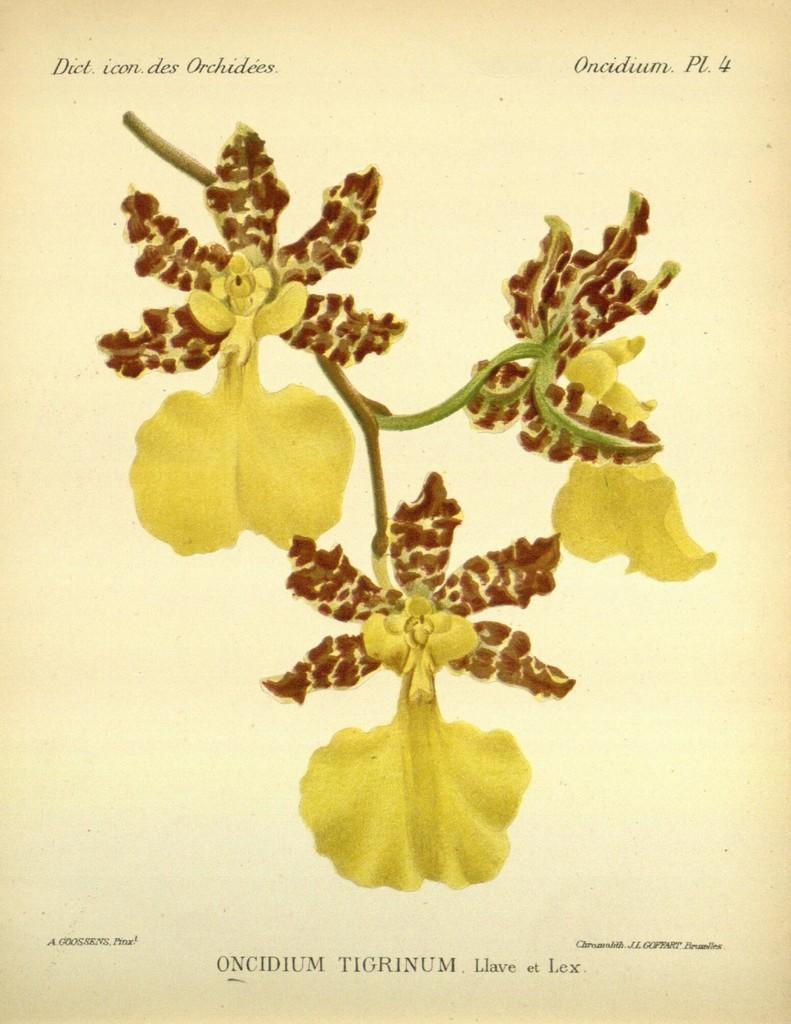<image>
Write a terse but informative summary of the picture. A drawing of orchids that says Oncidium Tigrinum at the bottom. 